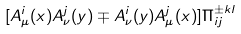Convert formula to latex. <formula><loc_0><loc_0><loc_500><loc_500>[ A _ { \mu } ^ { i } ( x ) A _ { \nu } ^ { j } ( y ) \mp A _ { \nu } ^ { i } ( y ) A _ { \mu } ^ { j } ( x ) ] \Pi _ { i j } ^ { \pm k l }</formula> 